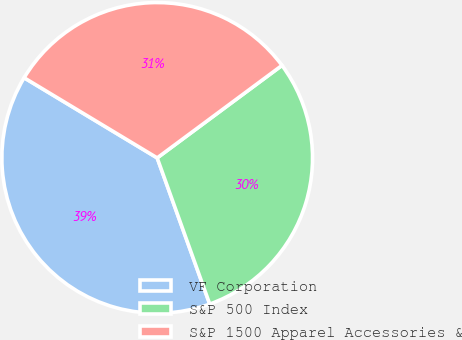Convert chart to OTSL. <chart><loc_0><loc_0><loc_500><loc_500><pie_chart><fcel>VF Corporation<fcel>S&P 500 Index<fcel>S&P 1500 Apparel Accessories &<nl><fcel>39.12%<fcel>29.66%<fcel>31.22%<nl></chart> 